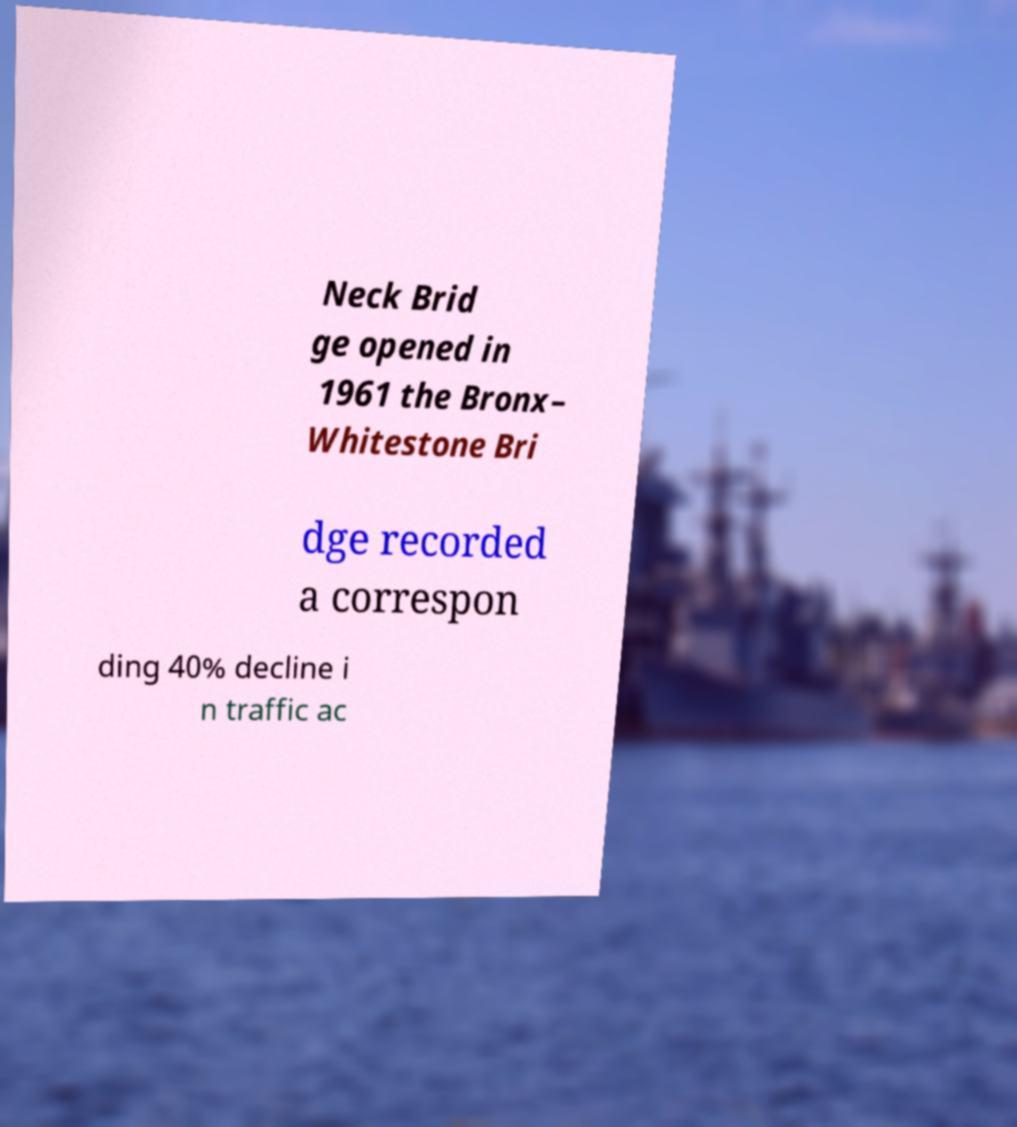Can you read and provide the text displayed in the image?This photo seems to have some interesting text. Can you extract and type it out for me? Neck Brid ge opened in 1961 the Bronx– Whitestone Bri dge recorded a correspon ding 40% decline i n traffic ac 